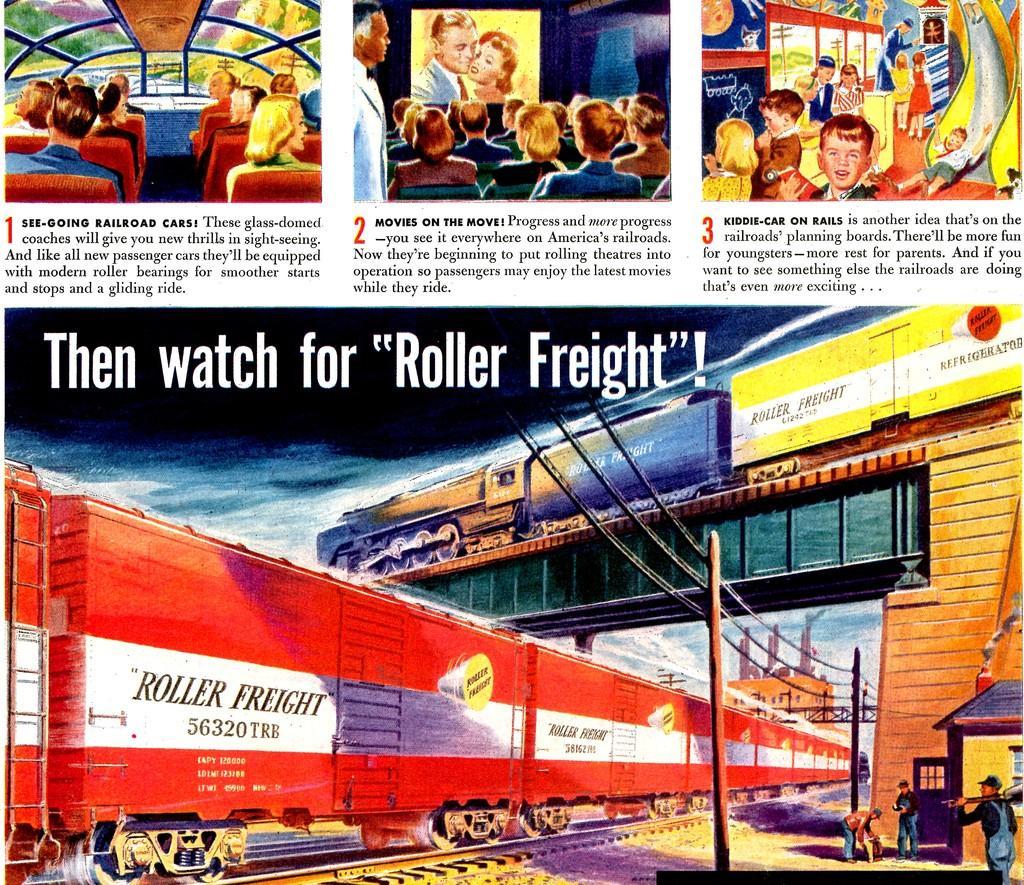Describe this image in one or two sentences. In this image we can see a paper. On the paper there are the pictures of bridge, locomotives, electric poles, electric cables, sheds, motor vehicles, display screens and people sitting on the chairs and standing on the floor. 